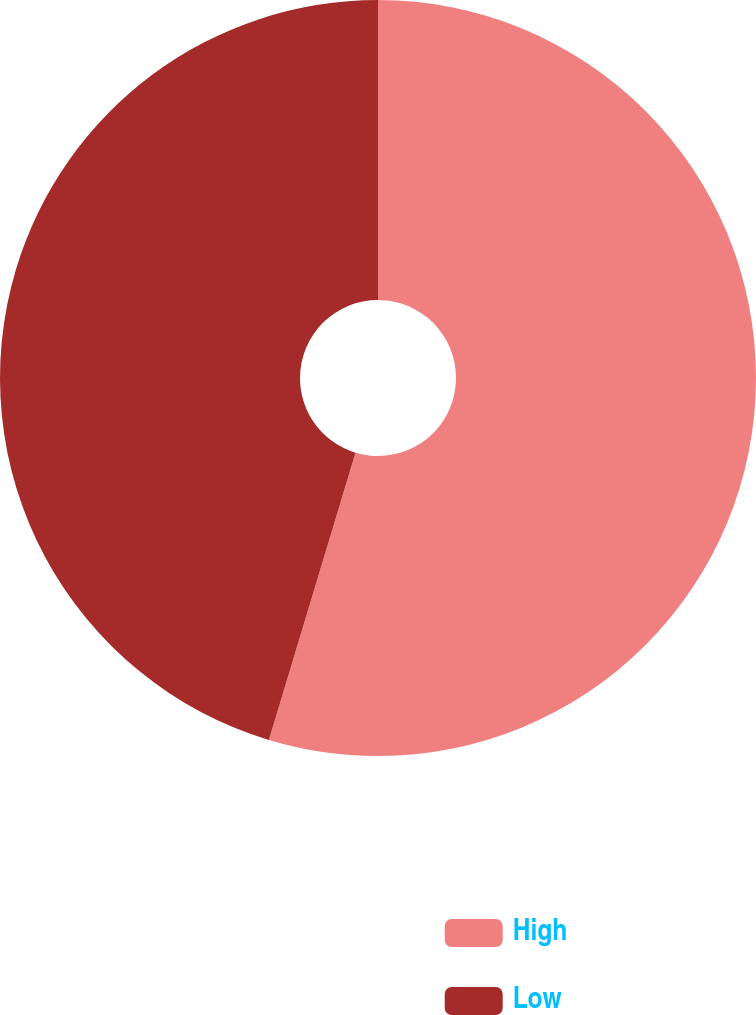<chart> <loc_0><loc_0><loc_500><loc_500><pie_chart><fcel>High<fcel>Low<nl><fcel>54.66%<fcel>45.34%<nl></chart> 